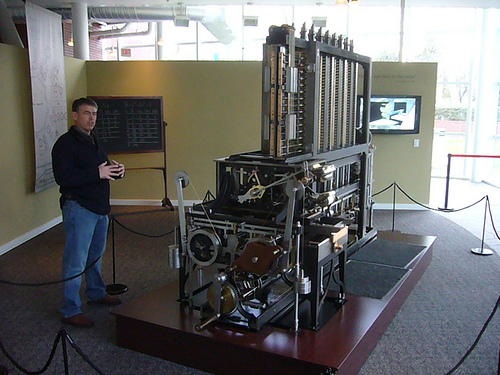<image>
Is the tv under the machine? No. The tv is not positioned under the machine. The vertical relationship between these objects is different. 